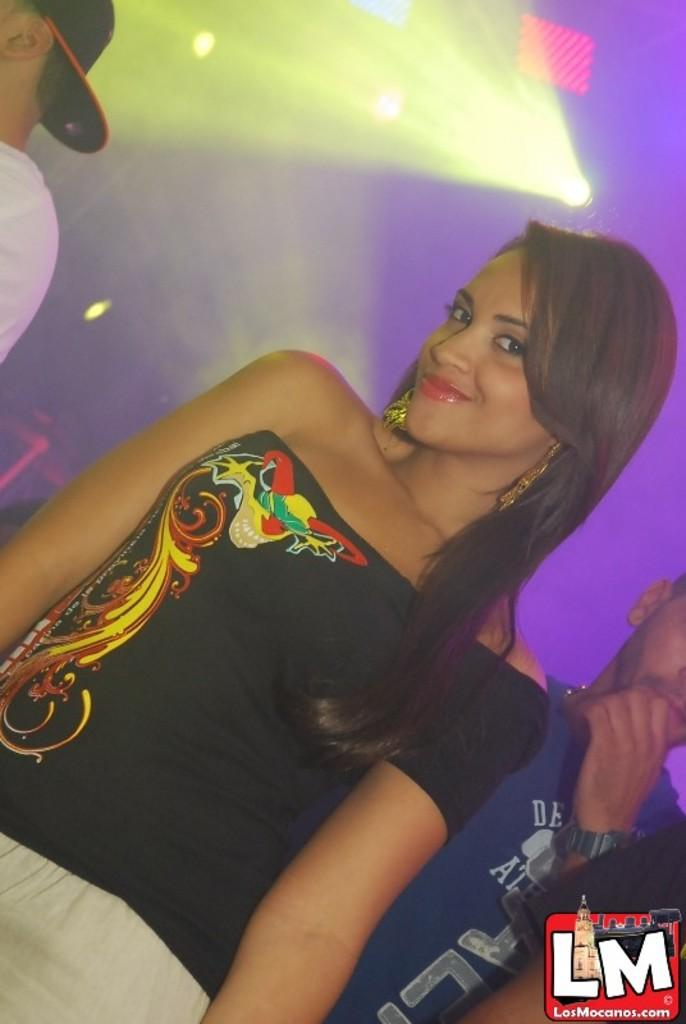What is the main subject in the image? There is a woman standing in the image. Are there any other people in the image? Yes, there are men standing in the background of the image. What can be seen on the top of the image? There are lightings visible on the top in the image. What type of necklace is the ghost wearing in the image? There is no ghost present in the image, so it is not possible to determine what type of necklace the ghost might be wearing. 